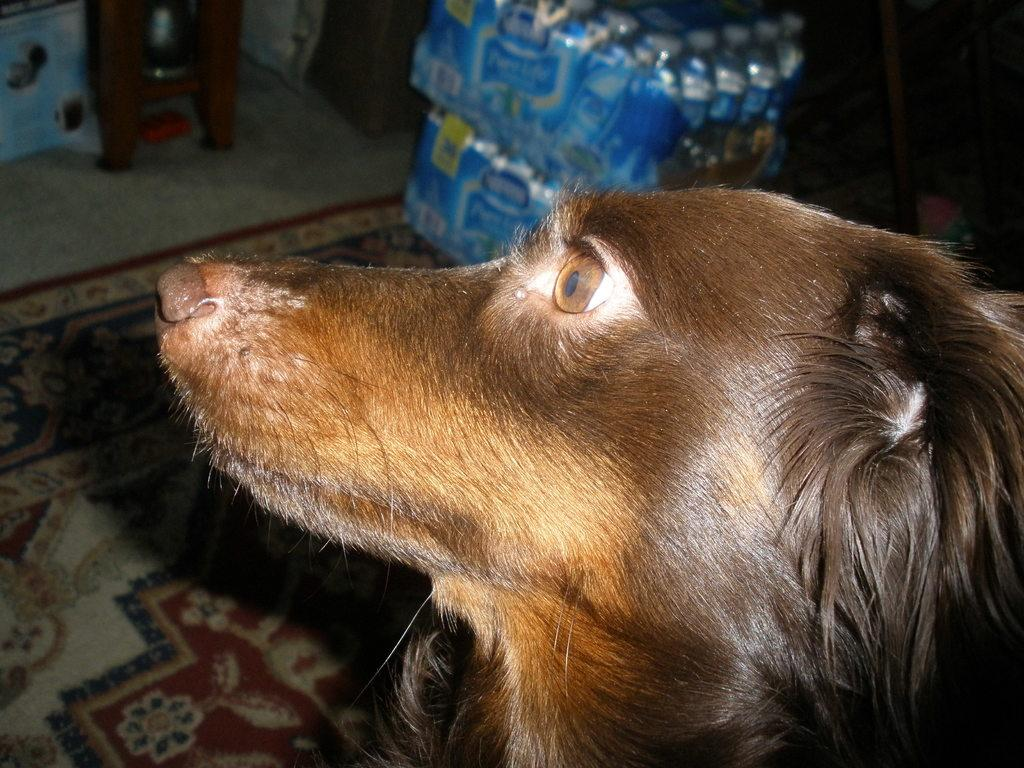What type of animal is present in the image? There is a dog in the image. What objects can be seen in the image besides the dog? There are bottles in the image. Where are the bottles located? The bottles are on a carpet. What type of guitar is being played by the dog in the image? There is no guitar present in the image; it only features a dog and bottles on a carpet. 